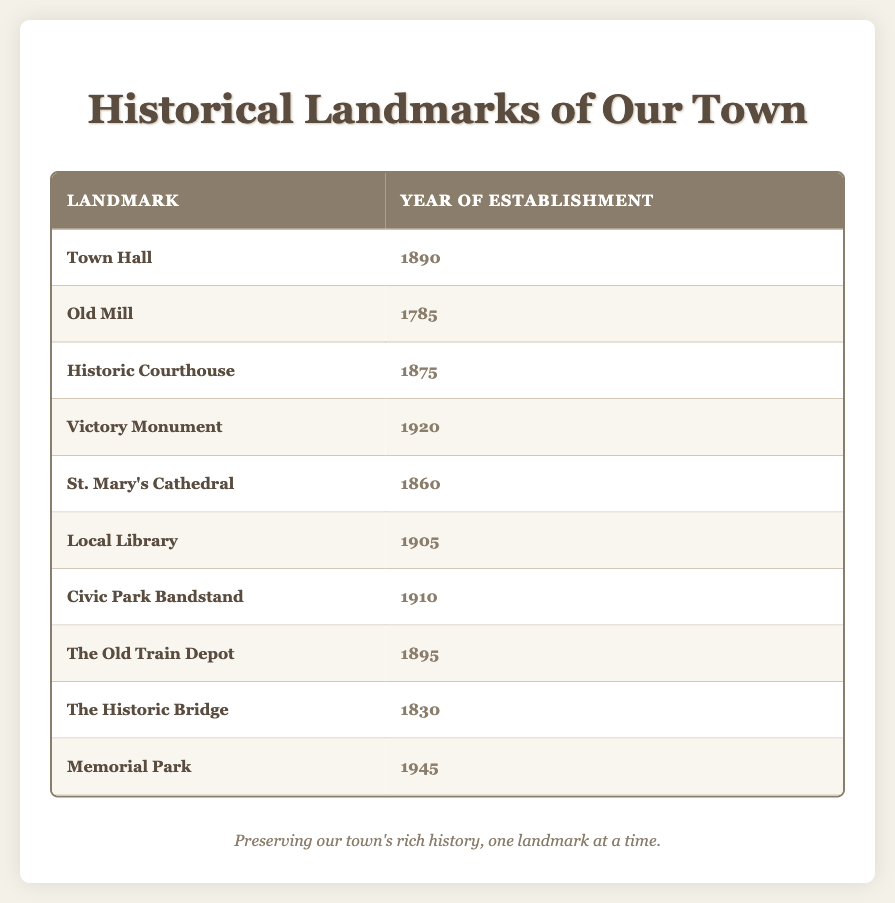What year was the Old Mill established? The table lists the Old Mill under the "Landmark" column, and its corresponding year in the "Year of Establishment" column is 1785.
Answer: 1785 How many landmarks were established before 1900? The landmarks established before 1900 are Old Mill (1785), Historic Courthouse (1875), St. Mary’s Cathedral (1860), and The Historic Bridge (1830). This counts to a total of four landmarks.
Answer: 4 What is the latest year of establishment among the landmarks? By checking the "Year of Establishment" column, the latest year given is 1945 for Memorial Park.
Answer: 1945 Is the Civic Park Bandstand older than the Local Library? The Civic Park Bandstand was established in 1910 while the Local Library was established in 1905. Since 1910 is later than 1905, the statement is false.
Answer: No Which landmark was established closest to 1900? To find this, we look for the years nearest to 1900. The years 1890 (Town Hall) and 1895 (The Old Train Depot) are closest. Among these, the Town Hall (1890) is earlier than The Old Train Depot (1895).
Answer: Town Hall How many years apart were the establishment of St. Mary’s Cathedral and the Victory Monument? St. Mary’s Cathedral was established in 1860 and the Victory Monument in 1920. The difference in years is 1920 - 1860 = 60 years.
Answer: 60 years What percentage of the listed landmarks were established in the 20th century? There are 3 landmarks (Victory Monument, Local Library, Civic Park Bandstand, and Memorial Park) established in the 20th century out of a total of 10 landmarks. The calculation is (4/10) * 100 = 40%.
Answer: 40% Which landmark was established first and what year was it built? By examining the "Year of Establishment" column, the Old Mill established in 1785 is the earliest landmark listed.
Answer: Old Mill, 1785 Are there any landmarks established in the 1800s with a year that ends in "0"? The landmarks from the 1800s are Old Mill (1785), Historic Courthouse (1875), St. Mary’s Cathedral (1860), Town Hall (1890), and The Old Train Depot (1895). Among these, Town Hall (1890) is the only one with a year ending in "0".
Answer: Yes, Town Hall (1890) Which two landmarks are separated by the largest difference in their establishment years? We look at the years of establishment: Old Mill (1785) and Memorial Park (1945) have the largest difference of 1945 - 1785 = 160 years.
Answer: Old Mill and Memorial Park, 160 years 